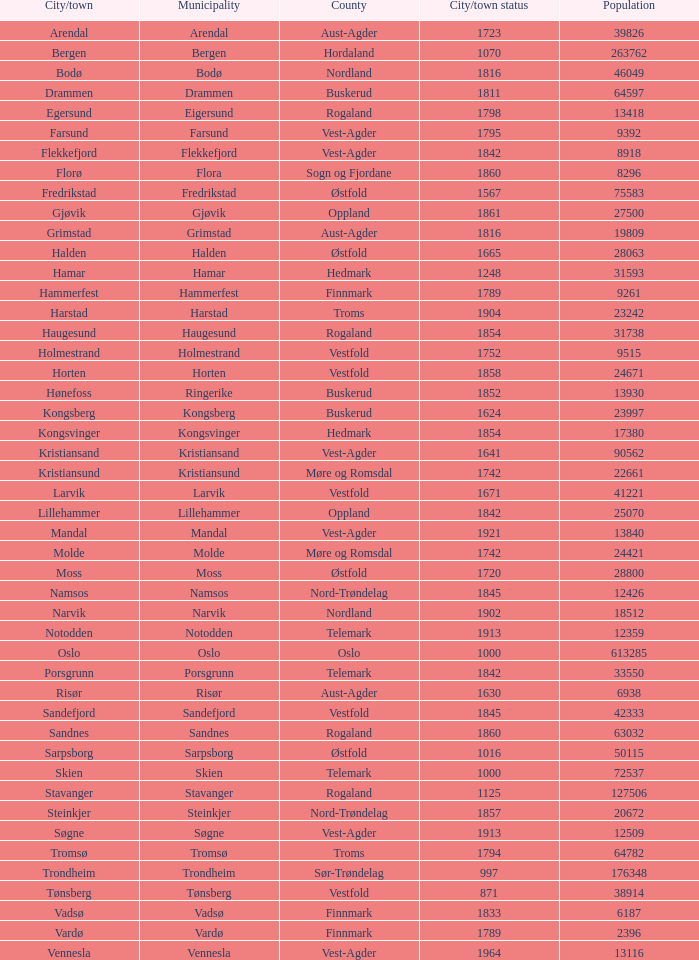Which localities within the finnmark county have populations greater than 618 Hammerfest. 